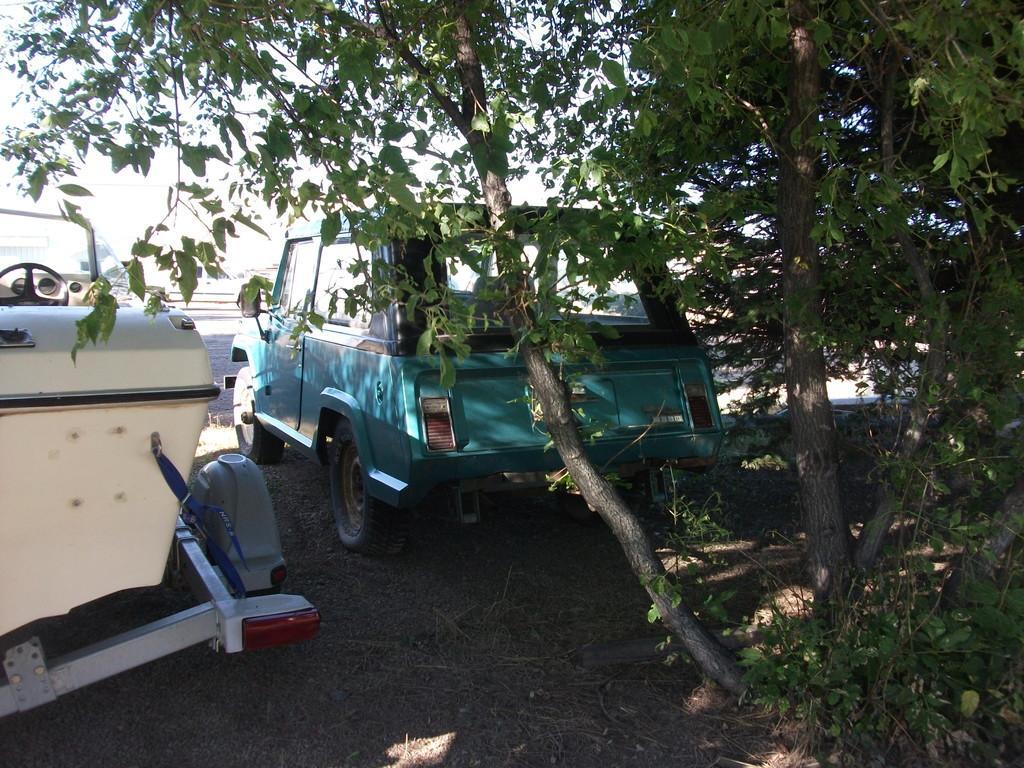How would you summarize this image in a sentence or two? In this picture we can see vehicles on the ground, trees and in the background we can see the sky. 